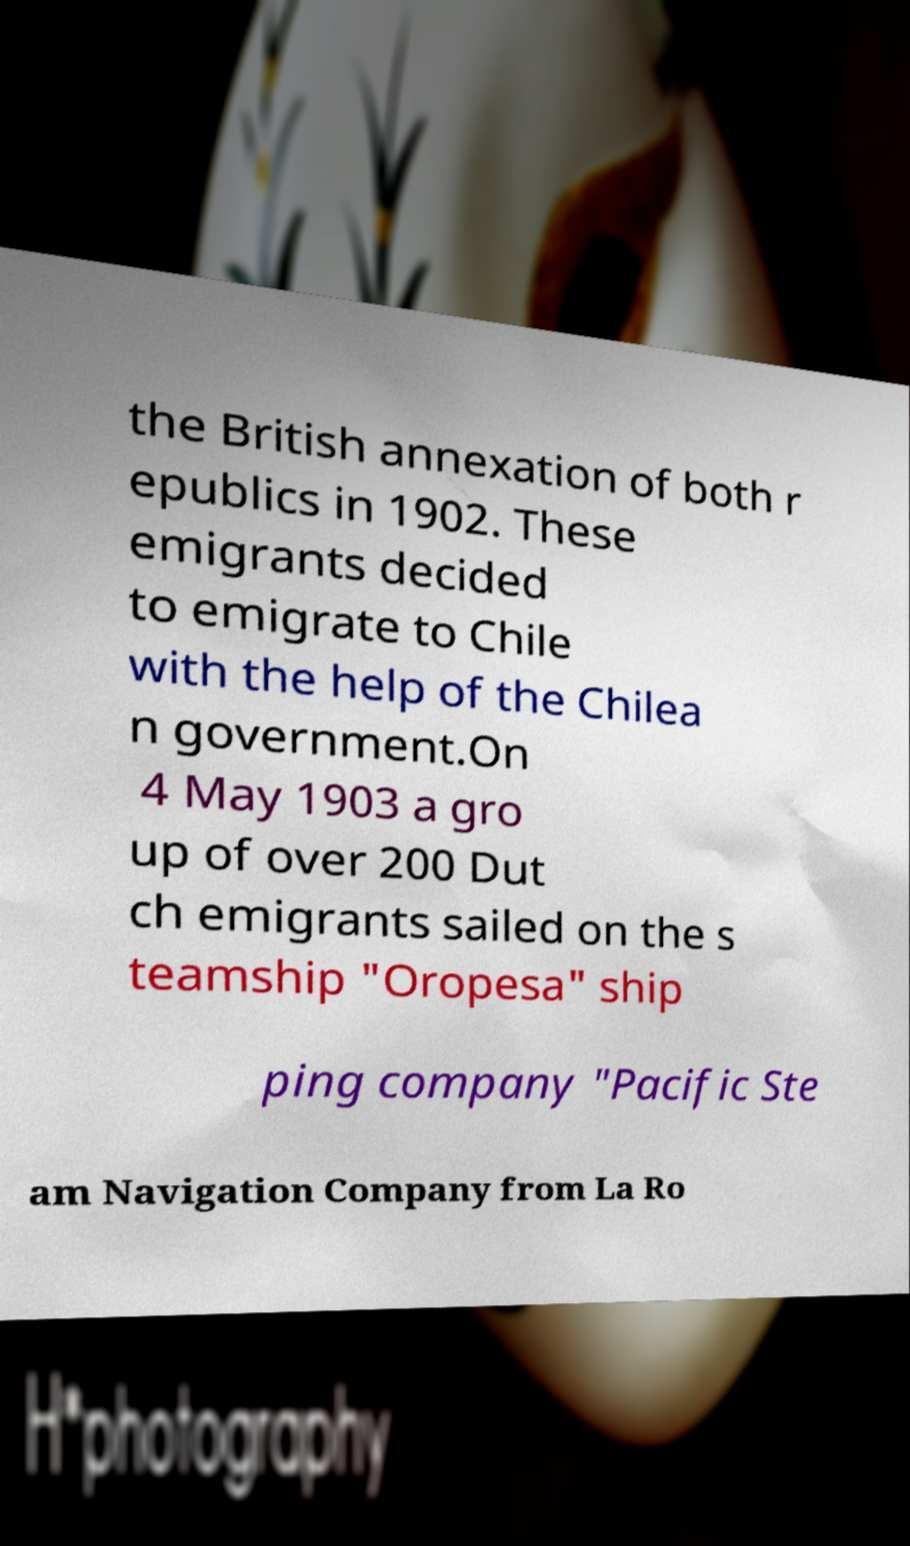I need the written content from this picture converted into text. Can you do that? the British annexation of both r epublics in 1902. These emigrants decided to emigrate to Chile with the help of the Chilea n government.On 4 May 1903 a gro up of over 200 Dut ch emigrants sailed on the s teamship "Oropesa" ship ping company "Pacific Ste am Navigation Company from La Ro 